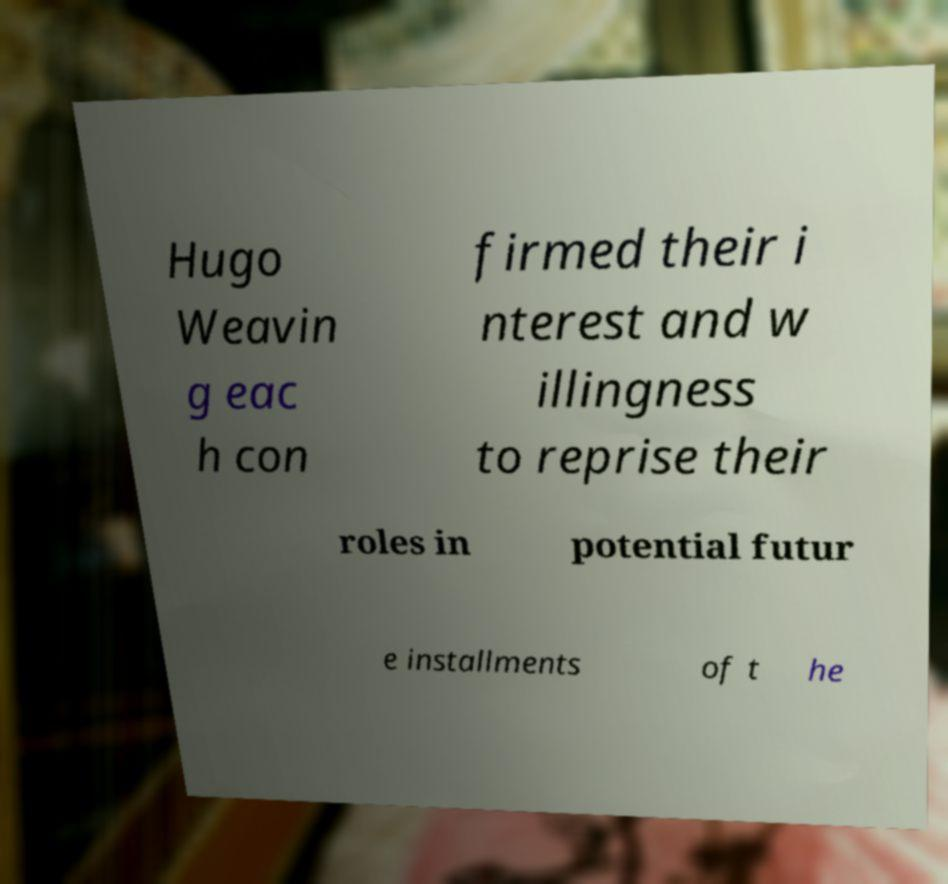What messages or text are displayed in this image? I need them in a readable, typed format. Hugo Weavin g eac h con firmed their i nterest and w illingness to reprise their roles in potential futur e installments of t he 